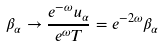Convert formula to latex. <formula><loc_0><loc_0><loc_500><loc_500>\beta _ { \alpha } \rightarrow \frac { e ^ { - \omega } u _ { \alpha } } { e ^ { \omega } T } = e ^ { - 2 \omega } \beta _ { \alpha }</formula> 